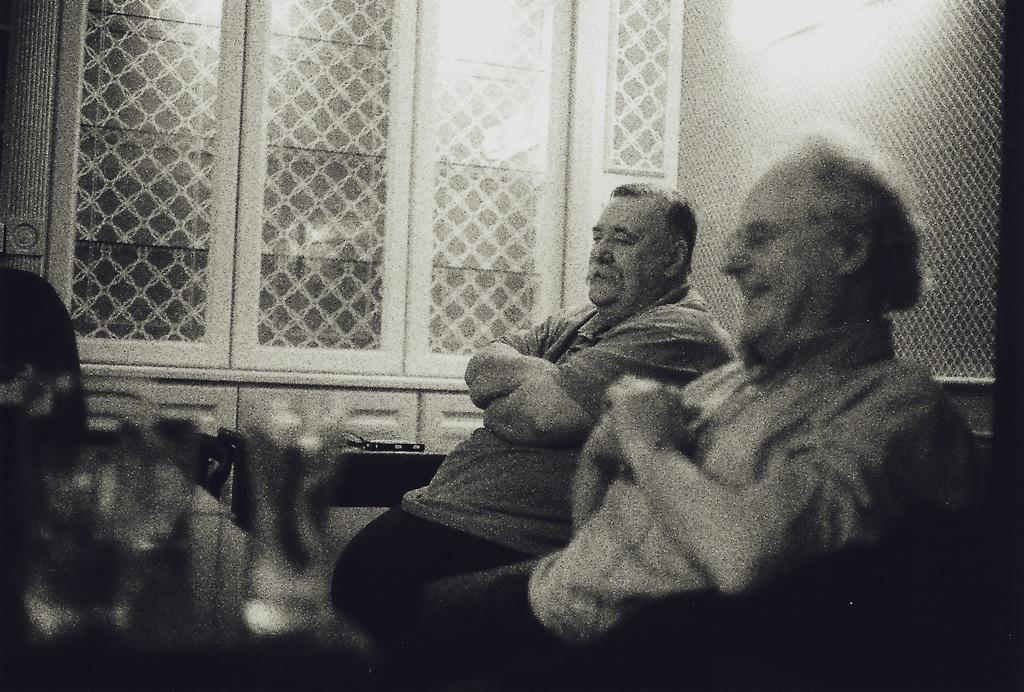How many people are sitting in the image? There are two men sitting in the image. What can be seen through the windows in the image? The details of what can be seen through the windows are not provided, but windows are visible in the image. What is present in the image that might be used for cooking? There is a grill present in the image. What type of bag is the man on the left holding in the image? There is no bag visible in the image; only two men sitting and windows are mentioned. 